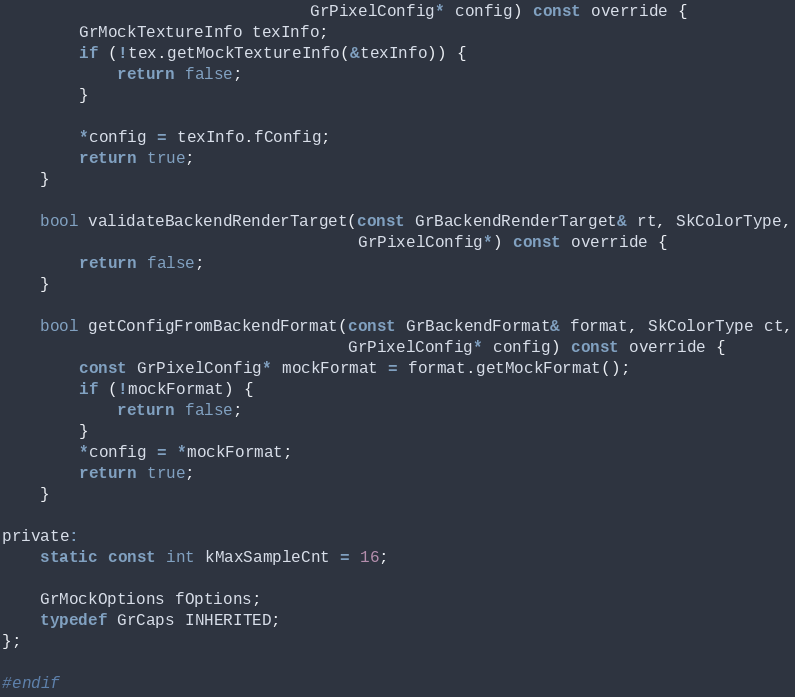<code> <loc_0><loc_0><loc_500><loc_500><_C_>                                GrPixelConfig* config) const override {
        GrMockTextureInfo texInfo;
        if (!tex.getMockTextureInfo(&texInfo)) {
            return false;
        }

        *config = texInfo.fConfig;
        return true;
    }

    bool validateBackendRenderTarget(const GrBackendRenderTarget& rt, SkColorType,
                                     GrPixelConfig*) const override {
        return false;
    }

    bool getConfigFromBackendFormat(const GrBackendFormat& format, SkColorType ct,
                                    GrPixelConfig* config) const override {
        const GrPixelConfig* mockFormat = format.getMockFormat();
        if (!mockFormat) {
            return false;
        }
        *config = *mockFormat;
        return true;
    }

private:
    static const int kMaxSampleCnt = 16;

    GrMockOptions fOptions;
    typedef GrCaps INHERITED;
};

#endif
</code> 